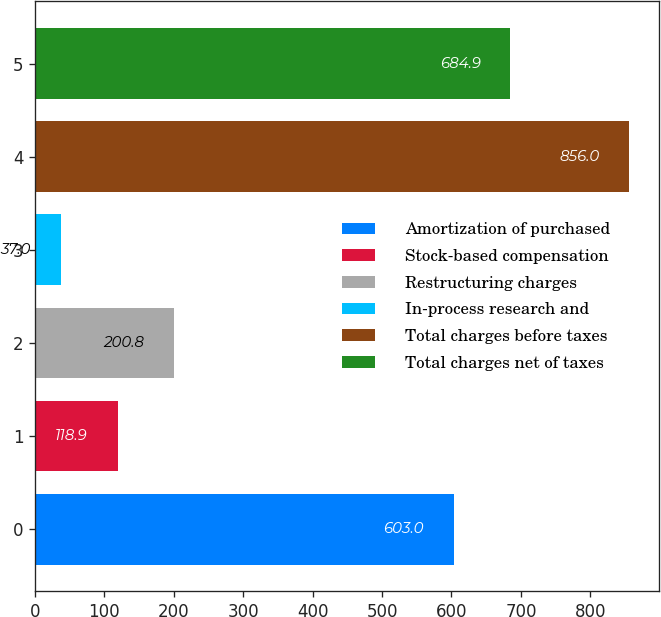Convert chart. <chart><loc_0><loc_0><loc_500><loc_500><bar_chart><fcel>Amortization of purchased<fcel>Stock-based compensation<fcel>Restructuring charges<fcel>In-process research and<fcel>Total charges before taxes<fcel>Total charges net of taxes<nl><fcel>603<fcel>118.9<fcel>200.8<fcel>37<fcel>856<fcel>684.9<nl></chart> 